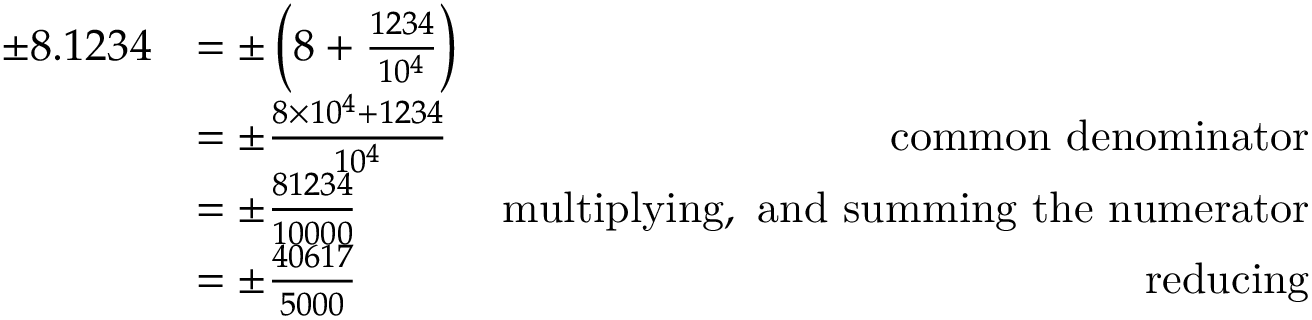<formula> <loc_0><loc_0><loc_500><loc_500>{ \begin{array} { r l r } { \pm 8 . 1 2 3 4 } & { = \pm \left ( 8 + { \frac { 1 2 3 4 } { 1 0 ^ { 4 } } } \right ) } & \\ & { = \pm { \frac { 8 \times 1 0 ^ { 4 } + 1 2 3 4 } { 1 0 ^ { 4 } } } } & { c o m m o n d e n o \min a t o r } \\ & { = \pm { \frac { 8 1 2 3 4 } { 1 0 0 0 0 } } } & { m u l t i p l y i n g , a n d s u m \min g t h e n u m e r a t o r } \\ & { = \pm { \frac { 4 0 6 1 7 } { 5 0 0 0 } } } & { r e d u c i n g } \end{array} }</formula> 